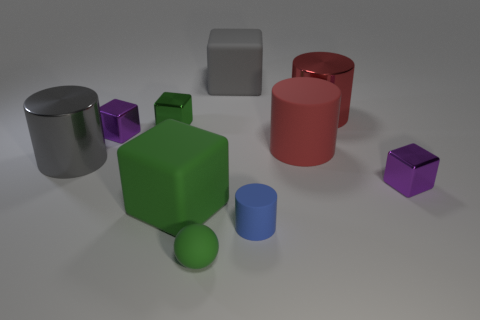Is there any particular pattern or theme to the colors of the objects? The objects in the image follow a somewhat muted and natural color palette, featuring primary and secondary colors. Each shaped object has a distinct color: the cubes are green, purple, and gray, the cylinders are red, blue, and silver, and the single sphere is green. This color scheme creates a balanced and harmonious visual setup without any apparent pattern other than the consistent application of color to shape types. 